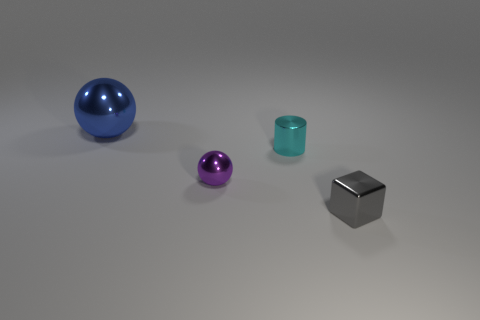Add 1 tiny things. How many objects exist? 5 Subtract all cubes. How many objects are left? 3 Add 1 tiny blocks. How many tiny blocks are left? 2 Add 1 small blue metallic objects. How many small blue metallic objects exist? 1 Subtract 0 cyan balls. How many objects are left? 4 Subtract all small gray objects. Subtract all cyan objects. How many objects are left? 2 